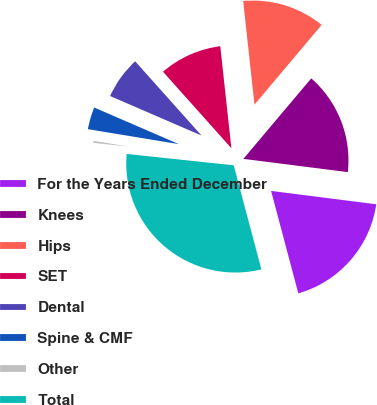Convert chart to OTSL. <chart><loc_0><loc_0><loc_500><loc_500><pie_chart><fcel>For the Years Ended December<fcel>Knees<fcel>Hips<fcel>SET<fcel>Dental<fcel>Spine & CMF<fcel>Other<fcel>Total<nl><fcel>18.85%<fcel>15.86%<fcel>12.87%<fcel>9.88%<fcel>6.89%<fcel>3.9%<fcel>0.91%<fcel>30.81%<nl></chart> 